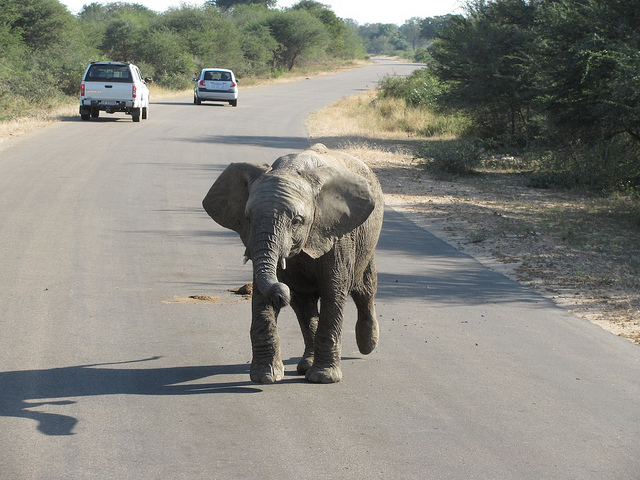Is the elephant adult or juvenile? The elephant appears to be a juvenile, as indicated by its smaller size in comparison to a fully grown adult elephant. Is it common for juvenile elephants to be alone like this? Usually not. Juvenile elephants are generally accompanied by their family herd for protection and guidance. This image may capture a rare moment or the elephant could be momentarily separated from its group. 